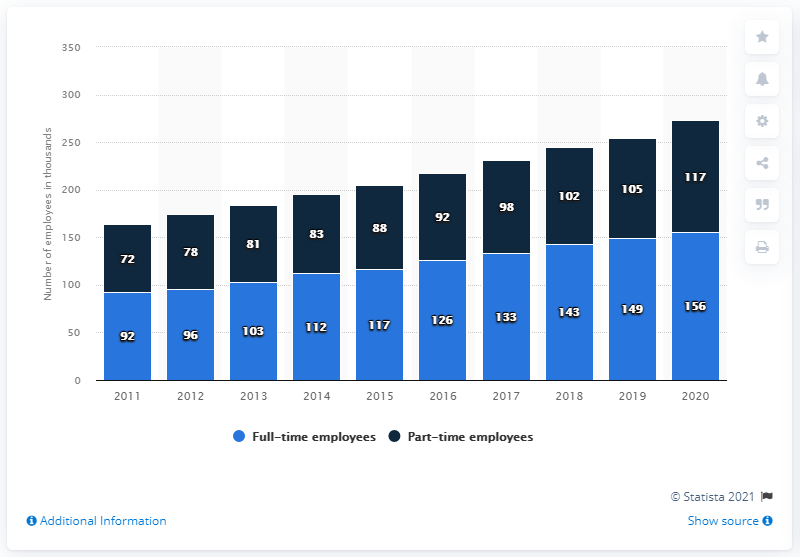Identify some key points in this picture. COSTCO had a total of full-time employees less than 100 thousand in number for 2 years. In 2011, COSTCO had the least number of part-time employees. 